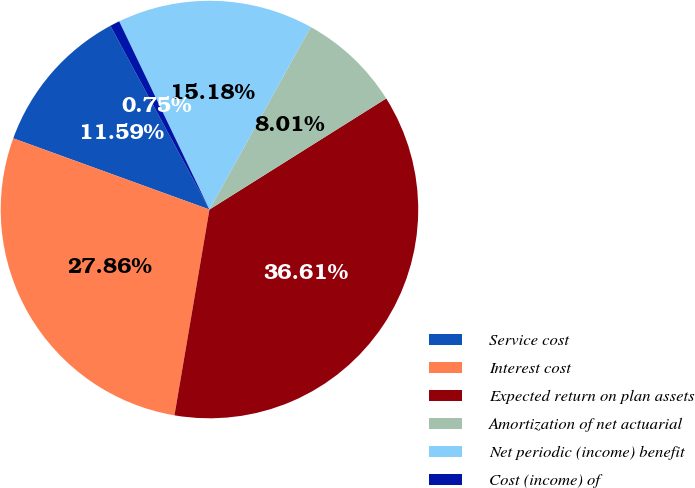<chart> <loc_0><loc_0><loc_500><loc_500><pie_chart><fcel>Service cost<fcel>Interest cost<fcel>Expected return on plan assets<fcel>Amortization of net actuarial<fcel>Net periodic (income) benefit<fcel>Cost (income) of<nl><fcel>11.59%<fcel>27.86%<fcel>36.61%<fcel>8.01%<fcel>15.18%<fcel>0.75%<nl></chart> 